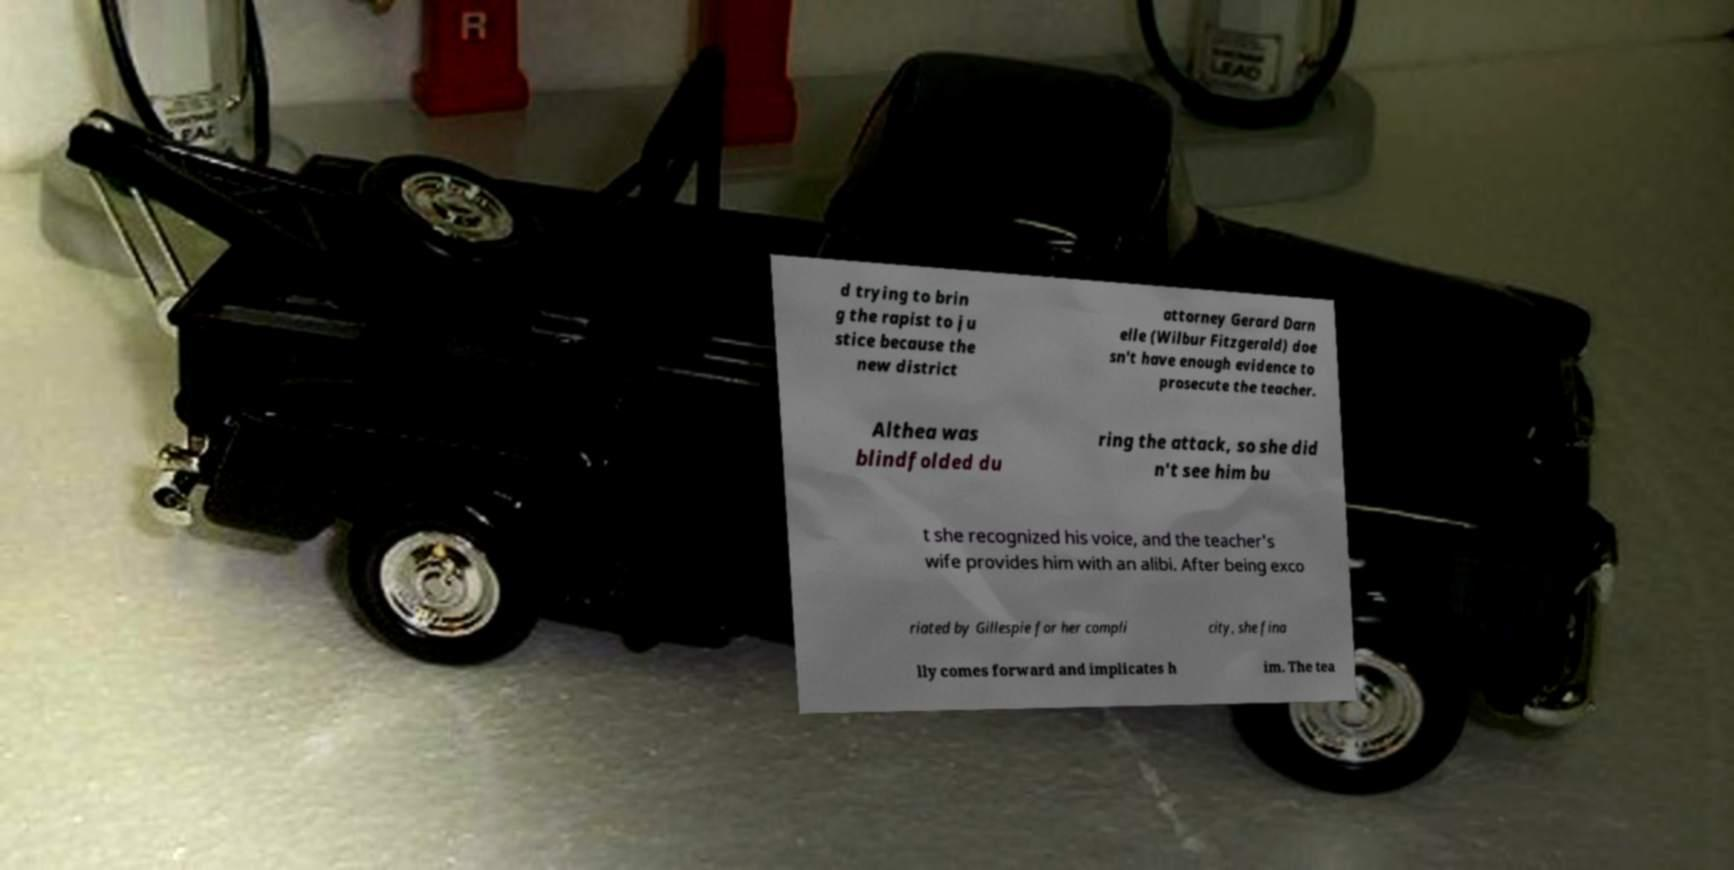Can you accurately transcribe the text from the provided image for me? d trying to brin g the rapist to ju stice because the new district attorney Gerard Darn elle (Wilbur Fitzgerald) doe sn't have enough evidence to prosecute the teacher. Althea was blindfolded du ring the attack, so she did n't see him bu t she recognized his voice, and the teacher's wife provides him with an alibi. After being exco riated by Gillespie for her compli city, she fina lly comes forward and implicates h im. The tea 